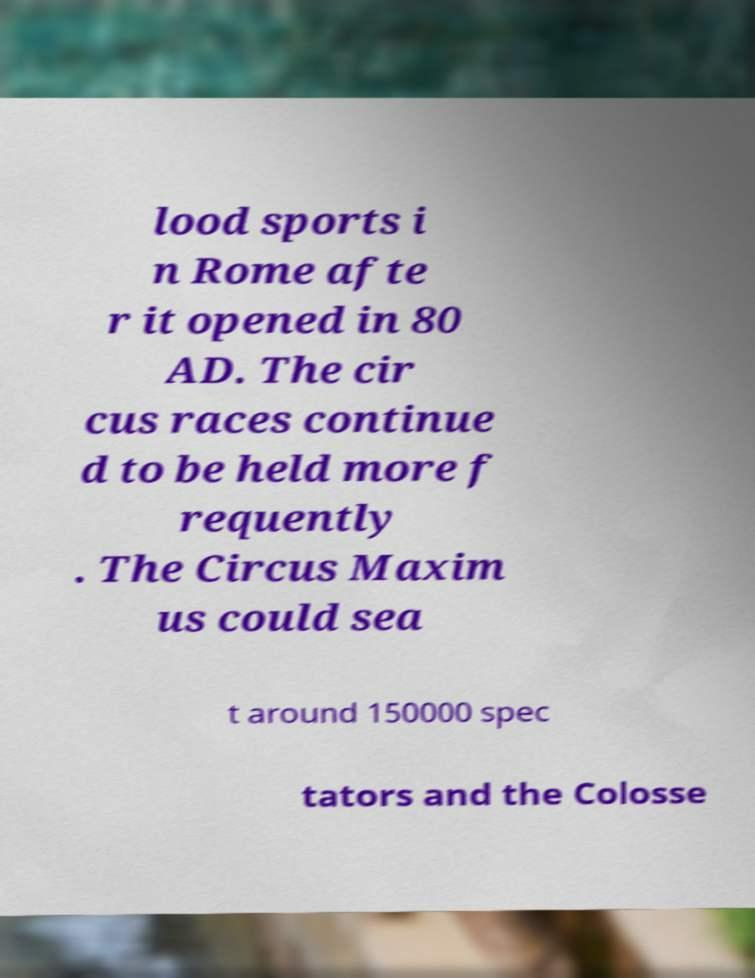There's text embedded in this image that I need extracted. Can you transcribe it verbatim? lood sports i n Rome afte r it opened in 80 AD. The cir cus races continue d to be held more f requently . The Circus Maxim us could sea t around 150000 spec tators and the Colosse 